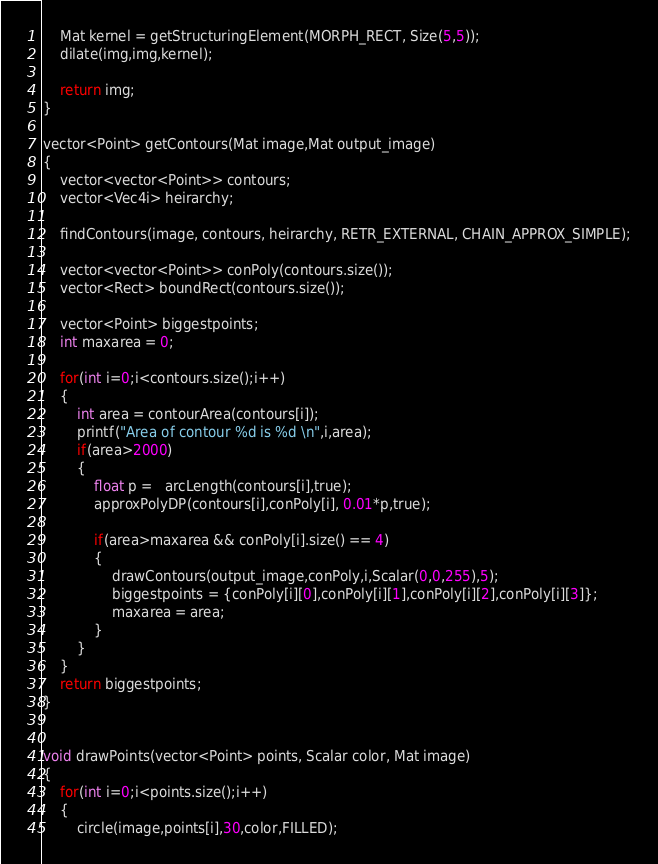<code> <loc_0><loc_0><loc_500><loc_500><_C++_>    Mat kernel = getStructuringElement(MORPH_RECT, Size(5,5));
    dilate(img,img,kernel);

    return img;
}

vector<Point> getContours(Mat image,Mat output_image)
{
    vector<vector<Point>> contours;
    vector<Vec4i> heirarchy;
    
    findContours(image, contours, heirarchy, RETR_EXTERNAL, CHAIN_APPROX_SIMPLE);
    
    vector<vector<Point>> conPoly(contours.size());
    vector<Rect> boundRect(contours.size());
    
    vector<Point> biggestpoints;
    int maxarea = 0;
    
    for(int i=0;i<contours.size();i++)
    {
        int area = contourArea(contours[i]);
        printf("Area of contour %d is %d \n",i,area);
        if(area>2000)
        {
            float p =   arcLength(contours[i],true);
            approxPolyDP(contours[i],conPoly[i], 0.01*p,true);

            if(area>maxarea && conPoly[i].size() == 4)
            {
                drawContours(output_image,conPoly,i,Scalar(0,0,255),5);
                biggestpoints = {conPoly[i][0],conPoly[i][1],conPoly[i][2],conPoly[i][3]};
                maxarea = area;
            }
        }
    }
    return biggestpoints;
}     


void drawPoints(vector<Point> points, Scalar color, Mat image)
{
    for(int i=0;i<points.size();i++)
    {
        circle(image,points[i],30,color,FILLED);</code> 